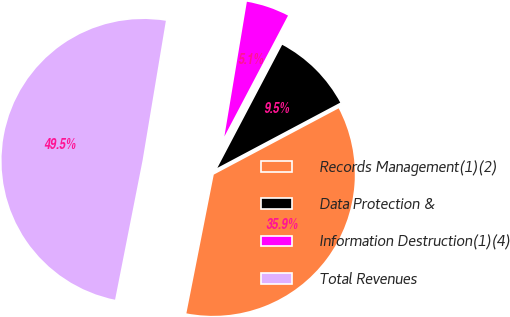<chart> <loc_0><loc_0><loc_500><loc_500><pie_chart><fcel>Records Management(1)(2)<fcel>Data Protection &<fcel>Information Destruction(1)(4)<fcel>Total Revenues<nl><fcel>35.87%<fcel>9.52%<fcel>5.08%<fcel>49.53%<nl></chart> 